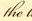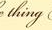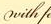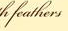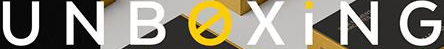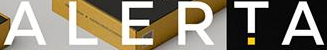What text appears in these images from left to right, separated by a semicolon? the; thing; with; feathers; UNBOXiNG; ALERTA 